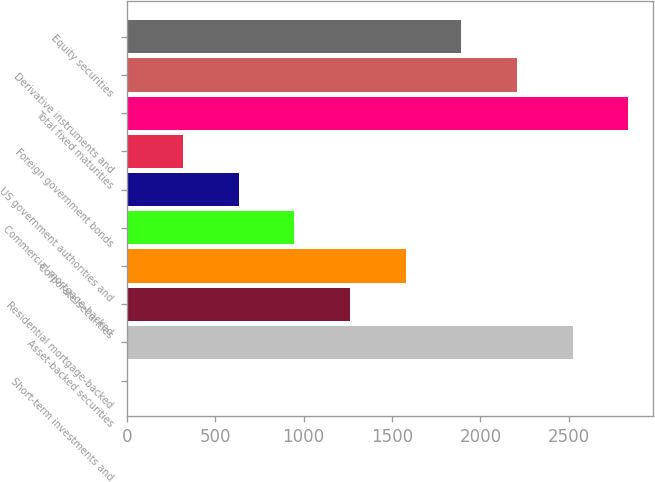Convert chart to OTSL. <chart><loc_0><loc_0><loc_500><loc_500><bar_chart><fcel>Short-term investments and<fcel>Asset-backed securities<fcel>Residential mortgage-backed<fcel>Corporate securities<fcel>Commercial mortgage-backed<fcel>US government authorities and<fcel>Foreign government bonds<fcel>Total fixed maturities<fcel>Derivative instruments and<fcel>Equity securities<nl><fcel>5<fcel>2521<fcel>1263<fcel>1577.5<fcel>948.5<fcel>634<fcel>319.5<fcel>2835.5<fcel>2206.5<fcel>1892<nl></chart> 